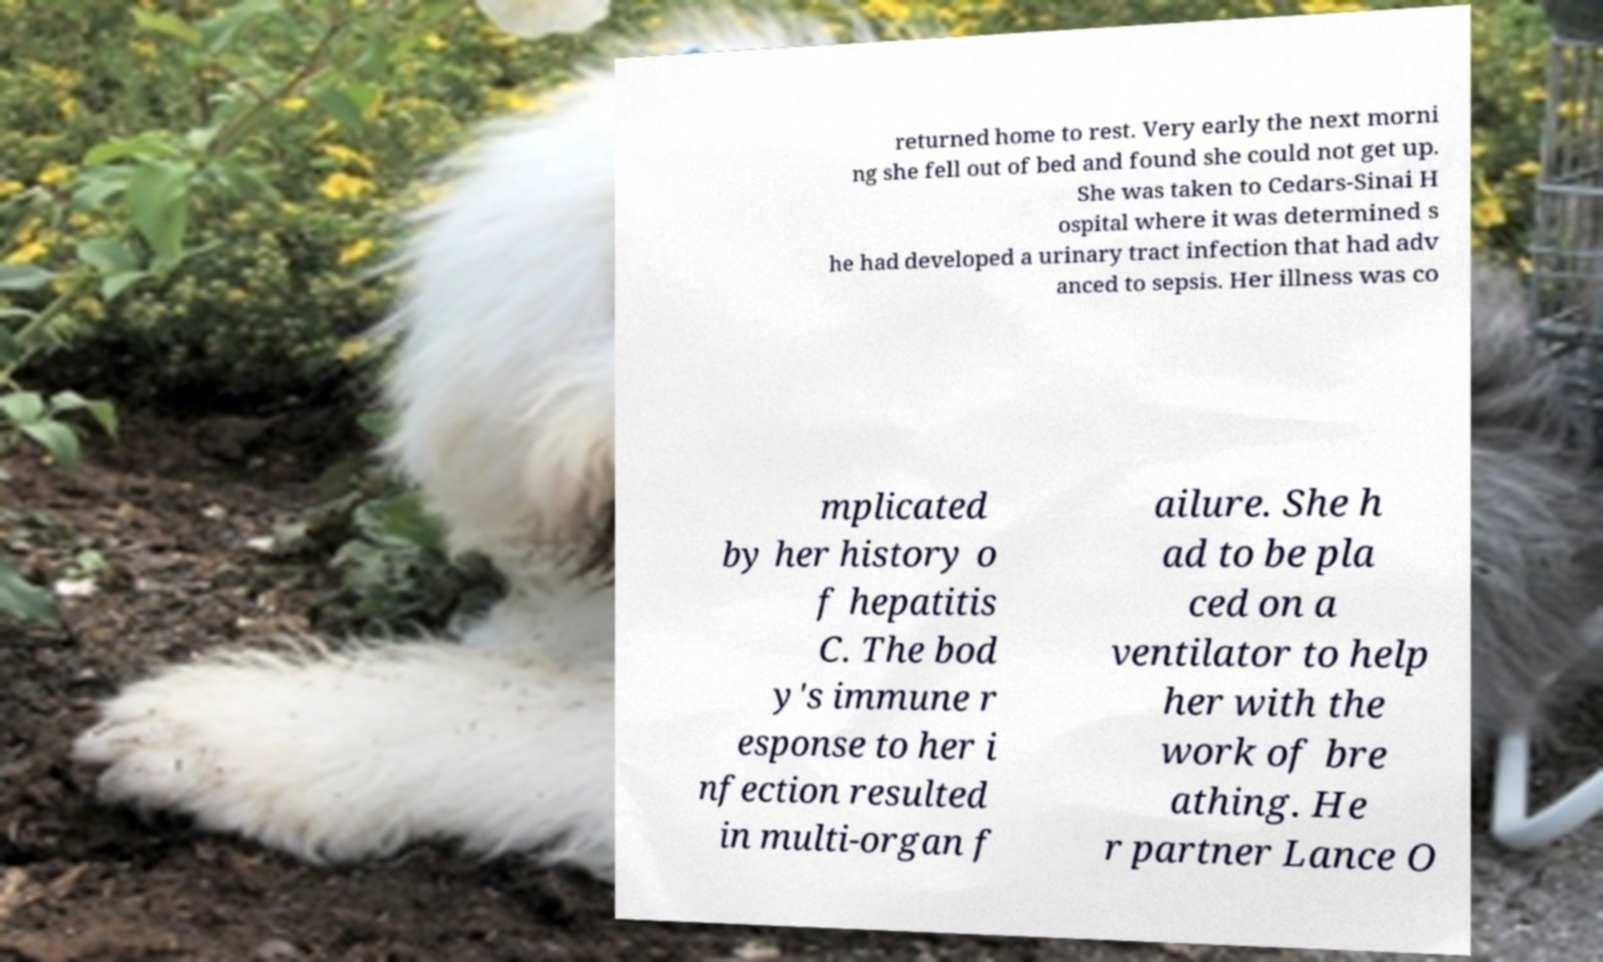Could you extract and type out the text from this image? returned home to rest. Very early the next morni ng she fell out of bed and found she could not get up. She was taken to Cedars-Sinai H ospital where it was determined s he had developed a urinary tract infection that had adv anced to sepsis. Her illness was co mplicated by her history o f hepatitis C. The bod y's immune r esponse to her i nfection resulted in multi-organ f ailure. She h ad to be pla ced on a ventilator to help her with the work of bre athing. He r partner Lance O 